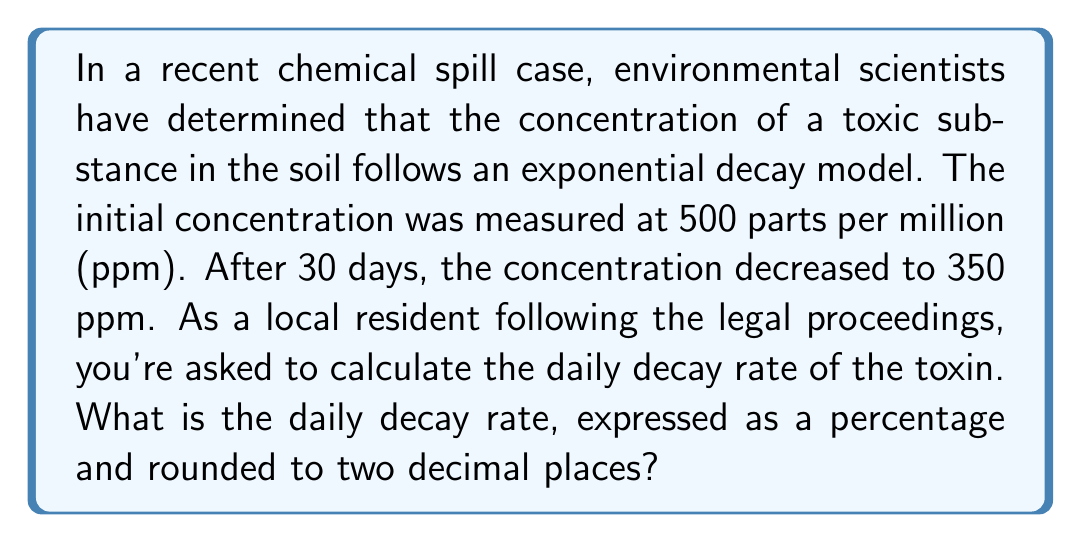Provide a solution to this math problem. To solve this problem, we'll use the exponential decay function:

$$C(t) = C_0 \cdot e^{-rt}$$

Where:
$C(t)$ is the concentration at time $t$
$C_0$ is the initial concentration
$r$ is the decay rate
$t$ is the time elapsed

We know:
$C_0 = 500$ ppm
$C(30) = 350$ ppm
$t = 30$ days

Let's plug these values into the equation:

$$350 = 500 \cdot e^{-r \cdot 30}$$

Now, we'll solve for $r$:

1) Divide both sides by 500:
   $$\frac{350}{500} = e^{-r \cdot 30}$$

2) Take the natural logarithm of both sides:
   $$\ln(\frac{350}{500}) = \ln(e^{-r \cdot 30})$$
   $$\ln(\frac{350}{500}) = -r \cdot 30$$

3) Solve for $r$:
   $$r = -\frac{1}{30} \ln(\frac{350}{500})$$
   $$r = -\frac{1}{30} \ln(0.7)$$
   $$r \approx 0.011887$$

4) Convert to a percentage:
   $$r \approx 0.011887 \cdot 100\% = 1.1887\%$$

5) Round to two decimal places:
   $$r \approx 1.19\%$$

Therefore, the daily decay rate is approximately 1.19%.
Answer: 1.19% 